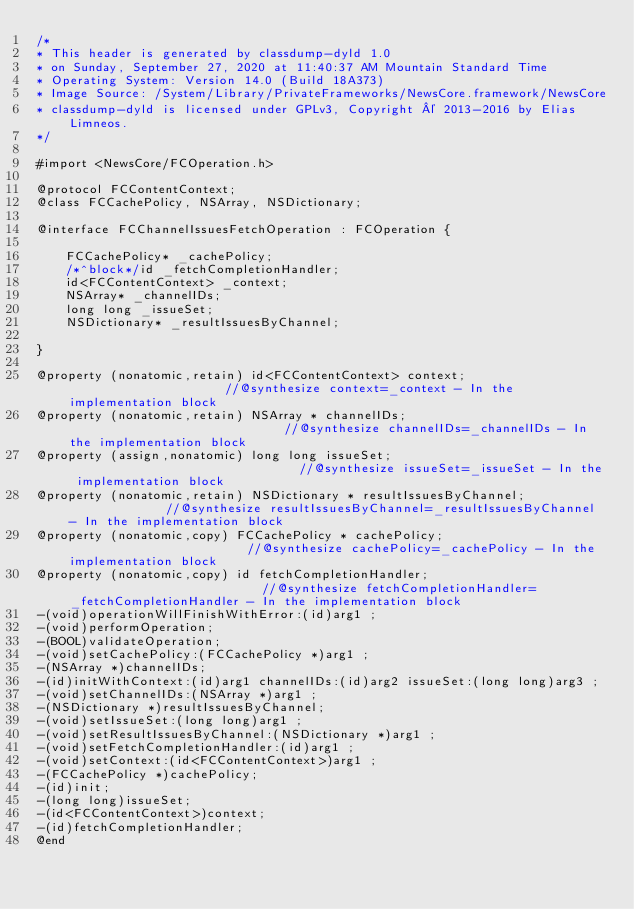Convert code to text. <code><loc_0><loc_0><loc_500><loc_500><_C_>/*
* This header is generated by classdump-dyld 1.0
* on Sunday, September 27, 2020 at 11:40:37 AM Mountain Standard Time
* Operating System: Version 14.0 (Build 18A373)
* Image Source: /System/Library/PrivateFrameworks/NewsCore.framework/NewsCore
* classdump-dyld is licensed under GPLv3, Copyright © 2013-2016 by Elias Limneos.
*/

#import <NewsCore/FCOperation.h>

@protocol FCContentContext;
@class FCCachePolicy, NSArray, NSDictionary;

@interface FCChannelIssuesFetchOperation : FCOperation {

	FCCachePolicy* _cachePolicy;
	/*^block*/id _fetchCompletionHandler;
	id<FCContentContext> _context;
	NSArray* _channelIDs;
	long long _issueSet;
	NSDictionary* _resultIssuesByChannel;

}

@property (nonatomic,retain) id<FCContentContext> context;                      //@synthesize context=_context - In the implementation block
@property (nonatomic,retain) NSArray * channelIDs;                              //@synthesize channelIDs=_channelIDs - In the implementation block
@property (assign,nonatomic) long long issueSet;                                //@synthesize issueSet=_issueSet - In the implementation block
@property (nonatomic,retain) NSDictionary * resultIssuesByChannel;              //@synthesize resultIssuesByChannel=_resultIssuesByChannel - In the implementation block
@property (nonatomic,copy) FCCachePolicy * cachePolicy;                         //@synthesize cachePolicy=_cachePolicy - In the implementation block
@property (nonatomic,copy) id fetchCompletionHandler;                           //@synthesize fetchCompletionHandler=_fetchCompletionHandler - In the implementation block
-(void)operationWillFinishWithError:(id)arg1 ;
-(void)performOperation;
-(BOOL)validateOperation;
-(void)setCachePolicy:(FCCachePolicy *)arg1 ;
-(NSArray *)channelIDs;
-(id)initWithContext:(id)arg1 channelIDs:(id)arg2 issueSet:(long long)arg3 ;
-(void)setChannelIDs:(NSArray *)arg1 ;
-(NSDictionary *)resultIssuesByChannel;
-(void)setIssueSet:(long long)arg1 ;
-(void)setResultIssuesByChannel:(NSDictionary *)arg1 ;
-(void)setFetchCompletionHandler:(id)arg1 ;
-(void)setContext:(id<FCContentContext>)arg1 ;
-(FCCachePolicy *)cachePolicy;
-(id)init;
-(long long)issueSet;
-(id<FCContentContext>)context;
-(id)fetchCompletionHandler;
@end

</code> 